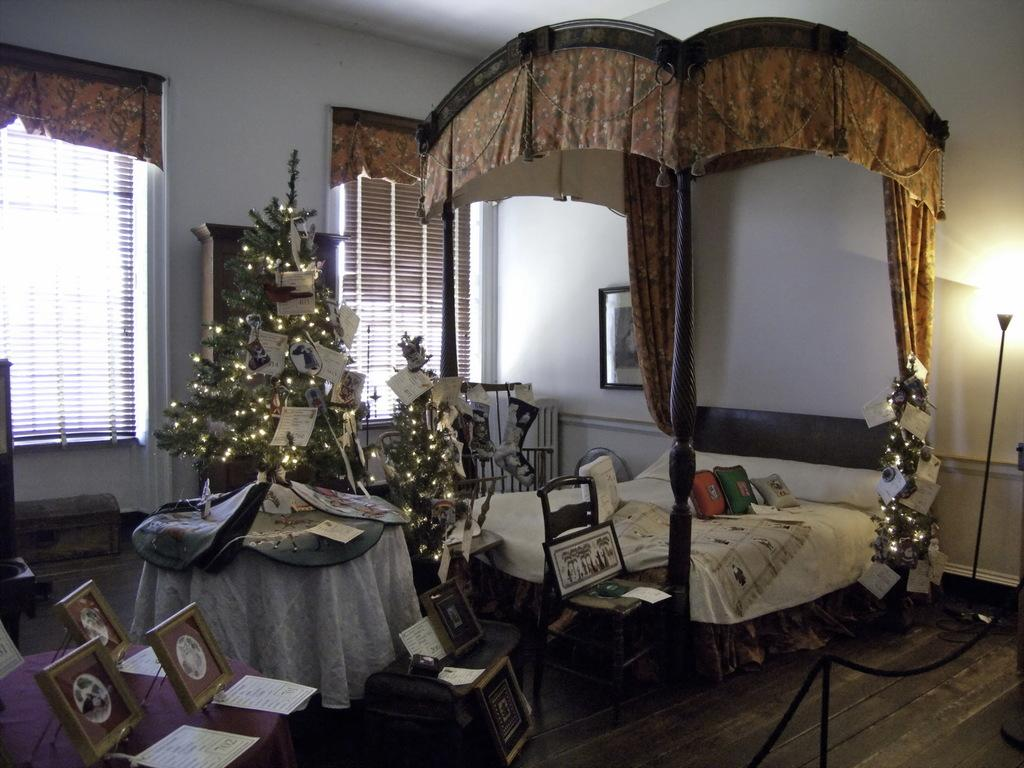What type of furniture is present in the image? There is a bed in the image. What holiday decoration can be seen in the image? There is a Christmas tree in the image. What architectural feature is visible on the wall in the image? There are windows on the wall in the image. Can you tell me how many hens are sitting on the bed in the image? There are no hens present in the image; it features a bed and a Christmas tree. What type of wire is used to decorate the Christmas tree in the image? There is no wire visible on the Christmas tree in the image. 